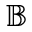Convert formula to latex. <formula><loc_0><loc_0><loc_500><loc_500>\mathbb { B }</formula> 